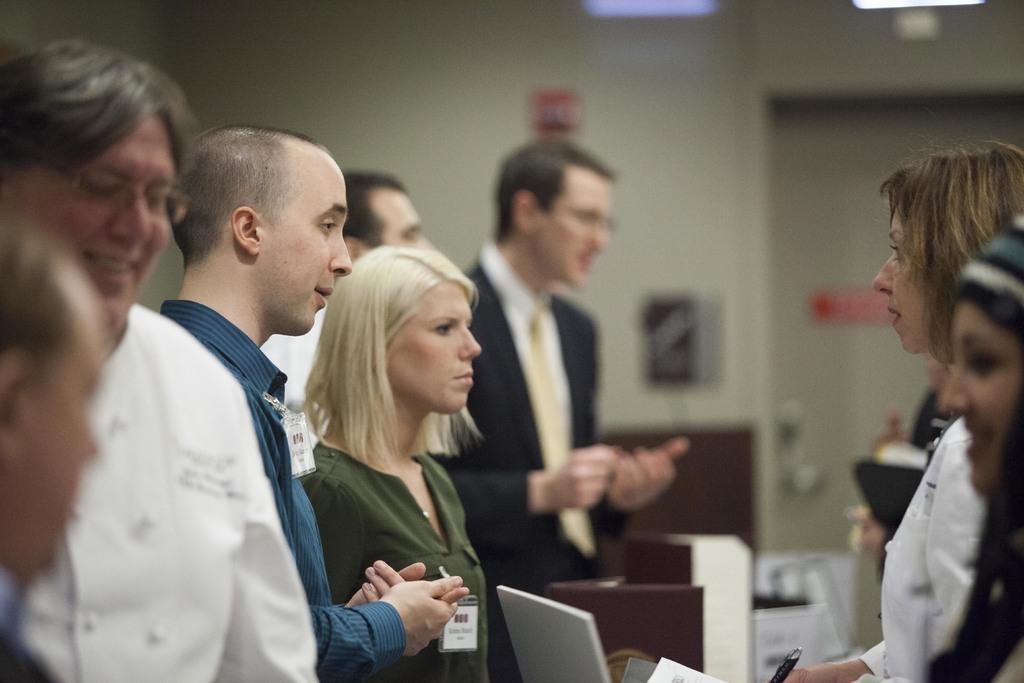How would you summarize this image in a sentence or two? In this image there are few people in the room, a laptop, few objects, some posters attached to the wall and a door. 